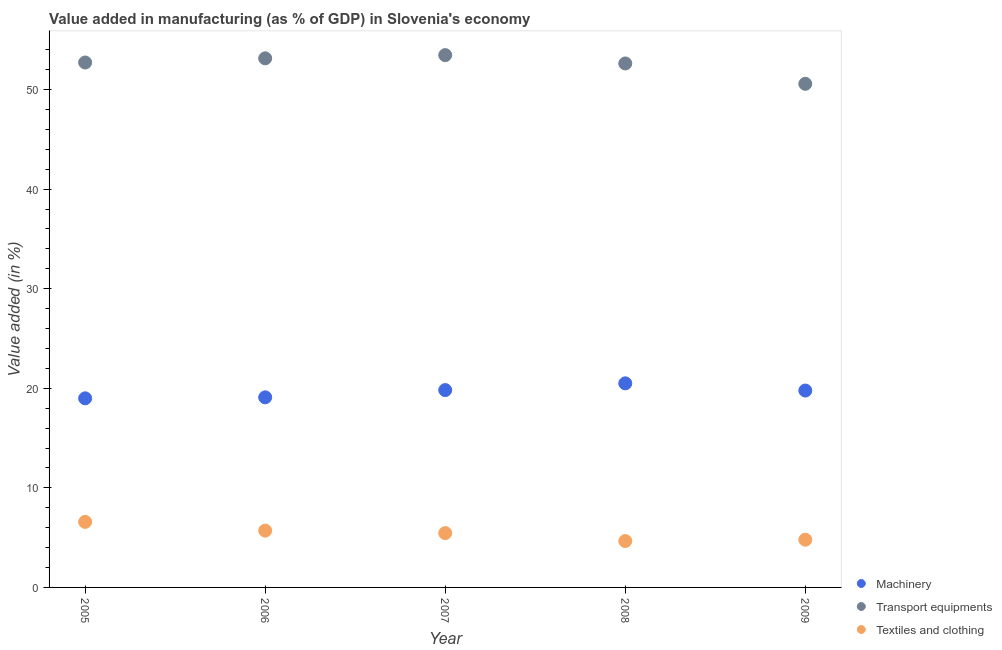Is the number of dotlines equal to the number of legend labels?
Your response must be concise. Yes. What is the value added in manufacturing textile and clothing in 2006?
Your answer should be very brief. 5.7. Across all years, what is the maximum value added in manufacturing textile and clothing?
Your answer should be very brief. 6.58. Across all years, what is the minimum value added in manufacturing machinery?
Give a very brief answer. 18.99. In which year was the value added in manufacturing transport equipments maximum?
Ensure brevity in your answer.  2007. What is the total value added in manufacturing machinery in the graph?
Make the answer very short. 98.16. What is the difference between the value added in manufacturing machinery in 2006 and that in 2008?
Ensure brevity in your answer.  -1.41. What is the difference between the value added in manufacturing machinery in 2007 and the value added in manufacturing transport equipments in 2005?
Your answer should be compact. -32.9. What is the average value added in manufacturing textile and clothing per year?
Your answer should be compact. 5.44. In the year 2008, what is the difference between the value added in manufacturing transport equipments and value added in manufacturing machinery?
Offer a very short reply. 32.12. In how many years, is the value added in manufacturing machinery greater than 10 %?
Ensure brevity in your answer.  5. What is the ratio of the value added in manufacturing transport equipments in 2006 to that in 2009?
Your answer should be compact. 1.05. Is the difference between the value added in manufacturing machinery in 2005 and 2007 greater than the difference between the value added in manufacturing transport equipments in 2005 and 2007?
Your response must be concise. No. What is the difference between the highest and the second highest value added in manufacturing textile and clothing?
Your response must be concise. 0.88. What is the difference between the highest and the lowest value added in manufacturing machinery?
Your answer should be compact. 1.51. In how many years, is the value added in manufacturing machinery greater than the average value added in manufacturing machinery taken over all years?
Offer a very short reply. 3. Is the sum of the value added in manufacturing transport equipments in 2007 and 2008 greater than the maximum value added in manufacturing machinery across all years?
Provide a succinct answer. Yes. Is it the case that in every year, the sum of the value added in manufacturing machinery and value added in manufacturing transport equipments is greater than the value added in manufacturing textile and clothing?
Your answer should be compact. Yes. Does the value added in manufacturing textile and clothing monotonically increase over the years?
Keep it short and to the point. No. Is the value added in manufacturing textile and clothing strictly greater than the value added in manufacturing machinery over the years?
Provide a succinct answer. No. How many dotlines are there?
Your answer should be compact. 3. How many years are there in the graph?
Ensure brevity in your answer.  5. What is the difference between two consecutive major ticks on the Y-axis?
Offer a terse response. 10. Are the values on the major ticks of Y-axis written in scientific E-notation?
Offer a terse response. No. Does the graph contain any zero values?
Give a very brief answer. No. Does the graph contain grids?
Your response must be concise. No. Where does the legend appear in the graph?
Your response must be concise. Bottom right. What is the title of the graph?
Your answer should be very brief. Value added in manufacturing (as % of GDP) in Slovenia's economy. What is the label or title of the X-axis?
Your answer should be very brief. Year. What is the label or title of the Y-axis?
Keep it short and to the point. Value added (in %). What is the Value added (in %) of Machinery in 2005?
Your response must be concise. 18.99. What is the Value added (in %) of Transport equipments in 2005?
Offer a very short reply. 52.71. What is the Value added (in %) in Textiles and clothing in 2005?
Keep it short and to the point. 6.58. What is the Value added (in %) in Machinery in 2006?
Your response must be concise. 19.09. What is the Value added (in %) of Transport equipments in 2006?
Ensure brevity in your answer.  53.13. What is the Value added (in %) of Textiles and clothing in 2006?
Provide a short and direct response. 5.7. What is the Value added (in %) in Machinery in 2007?
Offer a terse response. 19.82. What is the Value added (in %) in Transport equipments in 2007?
Offer a very short reply. 53.46. What is the Value added (in %) in Textiles and clothing in 2007?
Offer a very short reply. 5.45. What is the Value added (in %) in Machinery in 2008?
Provide a succinct answer. 20.5. What is the Value added (in %) in Transport equipments in 2008?
Give a very brief answer. 52.62. What is the Value added (in %) of Textiles and clothing in 2008?
Make the answer very short. 4.66. What is the Value added (in %) in Machinery in 2009?
Your response must be concise. 19.77. What is the Value added (in %) of Transport equipments in 2009?
Make the answer very short. 50.57. What is the Value added (in %) in Textiles and clothing in 2009?
Provide a short and direct response. 4.79. Across all years, what is the maximum Value added (in %) in Machinery?
Your answer should be compact. 20.5. Across all years, what is the maximum Value added (in %) of Transport equipments?
Offer a very short reply. 53.46. Across all years, what is the maximum Value added (in %) in Textiles and clothing?
Offer a very short reply. 6.58. Across all years, what is the minimum Value added (in %) of Machinery?
Offer a terse response. 18.99. Across all years, what is the minimum Value added (in %) of Transport equipments?
Ensure brevity in your answer.  50.57. Across all years, what is the minimum Value added (in %) in Textiles and clothing?
Your answer should be very brief. 4.66. What is the total Value added (in %) in Machinery in the graph?
Your response must be concise. 98.16. What is the total Value added (in %) of Transport equipments in the graph?
Keep it short and to the point. 262.49. What is the total Value added (in %) of Textiles and clothing in the graph?
Your answer should be very brief. 27.19. What is the difference between the Value added (in %) in Machinery in 2005 and that in 2006?
Keep it short and to the point. -0.1. What is the difference between the Value added (in %) in Transport equipments in 2005 and that in 2006?
Provide a succinct answer. -0.42. What is the difference between the Value added (in %) of Textiles and clothing in 2005 and that in 2006?
Provide a short and direct response. 0.88. What is the difference between the Value added (in %) of Machinery in 2005 and that in 2007?
Give a very brief answer. -0.83. What is the difference between the Value added (in %) in Transport equipments in 2005 and that in 2007?
Keep it short and to the point. -0.74. What is the difference between the Value added (in %) of Textiles and clothing in 2005 and that in 2007?
Your response must be concise. 1.13. What is the difference between the Value added (in %) in Machinery in 2005 and that in 2008?
Provide a succinct answer. -1.51. What is the difference between the Value added (in %) of Transport equipments in 2005 and that in 2008?
Your answer should be compact. 0.1. What is the difference between the Value added (in %) of Textiles and clothing in 2005 and that in 2008?
Make the answer very short. 1.93. What is the difference between the Value added (in %) in Machinery in 2005 and that in 2009?
Your answer should be very brief. -0.78. What is the difference between the Value added (in %) in Transport equipments in 2005 and that in 2009?
Offer a terse response. 2.14. What is the difference between the Value added (in %) in Textiles and clothing in 2005 and that in 2009?
Provide a short and direct response. 1.79. What is the difference between the Value added (in %) in Machinery in 2006 and that in 2007?
Your answer should be very brief. -0.73. What is the difference between the Value added (in %) of Transport equipments in 2006 and that in 2007?
Ensure brevity in your answer.  -0.32. What is the difference between the Value added (in %) in Textiles and clothing in 2006 and that in 2007?
Give a very brief answer. 0.25. What is the difference between the Value added (in %) of Machinery in 2006 and that in 2008?
Provide a succinct answer. -1.41. What is the difference between the Value added (in %) of Transport equipments in 2006 and that in 2008?
Make the answer very short. 0.51. What is the difference between the Value added (in %) of Textiles and clothing in 2006 and that in 2008?
Your answer should be compact. 1.05. What is the difference between the Value added (in %) in Machinery in 2006 and that in 2009?
Provide a succinct answer. -0.68. What is the difference between the Value added (in %) in Transport equipments in 2006 and that in 2009?
Provide a succinct answer. 2.56. What is the difference between the Value added (in %) of Textiles and clothing in 2006 and that in 2009?
Your response must be concise. 0.91. What is the difference between the Value added (in %) of Machinery in 2007 and that in 2008?
Ensure brevity in your answer.  -0.68. What is the difference between the Value added (in %) in Transport equipments in 2007 and that in 2008?
Ensure brevity in your answer.  0.84. What is the difference between the Value added (in %) of Textiles and clothing in 2007 and that in 2008?
Your response must be concise. 0.8. What is the difference between the Value added (in %) in Machinery in 2007 and that in 2009?
Make the answer very short. 0.05. What is the difference between the Value added (in %) in Transport equipments in 2007 and that in 2009?
Give a very brief answer. 2.88. What is the difference between the Value added (in %) in Textiles and clothing in 2007 and that in 2009?
Offer a terse response. 0.66. What is the difference between the Value added (in %) in Machinery in 2008 and that in 2009?
Provide a short and direct response. 0.72. What is the difference between the Value added (in %) in Transport equipments in 2008 and that in 2009?
Provide a succinct answer. 2.04. What is the difference between the Value added (in %) of Textiles and clothing in 2008 and that in 2009?
Ensure brevity in your answer.  -0.14. What is the difference between the Value added (in %) in Machinery in 2005 and the Value added (in %) in Transport equipments in 2006?
Give a very brief answer. -34.14. What is the difference between the Value added (in %) of Machinery in 2005 and the Value added (in %) of Textiles and clothing in 2006?
Offer a very short reply. 13.29. What is the difference between the Value added (in %) of Transport equipments in 2005 and the Value added (in %) of Textiles and clothing in 2006?
Your answer should be compact. 47.01. What is the difference between the Value added (in %) of Machinery in 2005 and the Value added (in %) of Transport equipments in 2007?
Offer a terse response. -34.47. What is the difference between the Value added (in %) of Machinery in 2005 and the Value added (in %) of Textiles and clothing in 2007?
Give a very brief answer. 13.54. What is the difference between the Value added (in %) in Transport equipments in 2005 and the Value added (in %) in Textiles and clothing in 2007?
Give a very brief answer. 47.26. What is the difference between the Value added (in %) of Machinery in 2005 and the Value added (in %) of Transport equipments in 2008?
Keep it short and to the point. -33.63. What is the difference between the Value added (in %) in Machinery in 2005 and the Value added (in %) in Textiles and clothing in 2008?
Ensure brevity in your answer.  14.33. What is the difference between the Value added (in %) in Transport equipments in 2005 and the Value added (in %) in Textiles and clothing in 2008?
Your answer should be very brief. 48.06. What is the difference between the Value added (in %) in Machinery in 2005 and the Value added (in %) in Transport equipments in 2009?
Your response must be concise. -31.58. What is the difference between the Value added (in %) in Machinery in 2005 and the Value added (in %) in Textiles and clothing in 2009?
Keep it short and to the point. 14.2. What is the difference between the Value added (in %) in Transport equipments in 2005 and the Value added (in %) in Textiles and clothing in 2009?
Provide a succinct answer. 47.92. What is the difference between the Value added (in %) in Machinery in 2006 and the Value added (in %) in Transport equipments in 2007?
Your response must be concise. -34.37. What is the difference between the Value added (in %) of Machinery in 2006 and the Value added (in %) of Textiles and clothing in 2007?
Keep it short and to the point. 13.63. What is the difference between the Value added (in %) in Transport equipments in 2006 and the Value added (in %) in Textiles and clothing in 2007?
Offer a terse response. 47.68. What is the difference between the Value added (in %) of Machinery in 2006 and the Value added (in %) of Transport equipments in 2008?
Your answer should be very brief. -33.53. What is the difference between the Value added (in %) of Machinery in 2006 and the Value added (in %) of Textiles and clothing in 2008?
Offer a very short reply. 14.43. What is the difference between the Value added (in %) of Transport equipments in 2006 and the Value added (in %) of Textiles and clothing in 2008?
Ensure brevity in your answer.  48.48. What is the difference between the Value added (in %) in Machinery in 2006 and the Value added (in %) in Transport equipments in 2009?
Keep it short and to the point. -31.48. What is the difference between the Value added (in %) in Machinery in 2006 and the Value added (in %) in Textiles and clothing in 2009?
Your response must be concise. 14.3. What is the difference between the Value added (in %) in Transport equipments in 2006 and the Value added (in %) in Textiles and clothing in 2009?
Offer a terse response. 48.34. What is the difference between the Value added (in %) in Machinery in 2007 and the Value added (in %) in Transport equipments in 2008?
Your response must be concise. -32.8. What is the difference between the Value added (in %) of Machinery in 2007 and the Value added (in %) of Textiles and clothing in 2008?
Give a very brief answer. 15.16. What is the difference between the Value added (in %) of Transport equipments in 2007 and the Value added (in %) of Textiles and clothing in 2008?
Keep it short and to the point. 48.8. What is the difference between the Value added (in %) in Machinery in 2007 and the Value added (in %) in Transport equipments in 2009?
Keep it short and to the point. -30.76. What is the difference between the Value added (in %) in Machinery in 2007 and the Value added (in %) in Textiles and clothing in 2009?
Keep it short and to the point. 15.02. What is the difference between the Value added (in %) in Transport equipments in 2007 and the Value added (in %) in Textiles and clothing in 2009?
Keep it short and to the point. 48.66. What is the difference between the Value added (in %) in Machinery in 2008 and the Value added (in %) in Transport equipments in 2009?
Ensure brevity in your answer.  -30.08. What is the difference between the Value added (in %) of Machinery in 2008 and the Value added (in %) of Textiles and clothing in 2009?
Offer a very short reply. 15.7. What is the difference between the Value added (in %) in Transport equipments in 2008 and the Value added (in %) in Textiles and clothing in 2009?
Offer a terse response. 47.83. What is the average Value added (in %) of Machinery per year?
Provide a short and direct response. 19.63. What is the average Value added (in %) of Transport equipments per year?
Your answer should be compact. 52.5. What is the average Value added (in %) in Textiles and clothing per year?
Provide a short and direct response. 5.44. In the year 2005, what is the difference between the Value added (in %) of Machinery and Value added (in %) of Transport equipments?
Give a very brief answer. -33.72. In the year 2005, what is the difference between the Value added (in %) of Machinery and Value added (in %) of Textiles and clothing?
Your answer should be very brief. 12.41. In the year 2005, what is the difference between the Value added (in %) of Transport equipments and Value added (in %) of Textiles and clothing?
Offer a terse response. 46.13. In the year 2006, what is the difference between the Value added (in %) of Machinery and Value added (in %) of Transport equipments?
Ensure brevity in your answer.  -34.04. In the year 2006, what is the difference between the Value added (in %) in Machinery and Value added (in %) in Textiles and clothing?
Your response must be concise. 13.38. In the year 2006, what is the difference between the Value added (in %) of Transport equipments and Value added (in %) of Textiles and clothing?
Your response must be concise. 47.43. In the year 2007, what is the difference between the Value added (in %) in Machinery and Value added (in %) in Transport equipments?
Your answer should be compact. -33.64. In the year 2007, what is the difference between the Value added (in %) of Machinery and Value added (in %) of Textiles and clothing?
Give a very brief answer. 14.36. In the year 2007, what is the difference between the Value added (in %) in Transport equipments and Value added (in %) in Textiles and clothing?
Give a very brief answer. 48. In the year 2008, what is the difference between the Value added (in %) of Machinery and Value added (in %) of Transport equipments?
Provide a short and direct response. -32.12. In the year 2008, what is the difference between the Value added (in %) of Machinery and Value added (in %) of Textiles and clothing?
Make the answer very short. 15.84. In the year 2008, what is the difference between the Value added (in %) of Transport equipments and Value added (in %) of Textiles and clothing?
Your answer should be very brief. 47.96. In the year 2009, what is the difference between the Value added (in %) of Machinery and Value added (in %) of Transport equipments?
Your answer should be compact. -30.8. In the year 2009, what is the difference between the Value added (in %) of Machinery and Value added (in %) of Textiles and clothing?
Ensure brevity in your answer.  14.98. In the year 2009, what is the difference between the Value added (in %) of Transport equipments and Value added (in %) of Textiles and clothing?
Your response must be concise. 45.78. What is the ratio of the Value added (in %) of Textiles and clothing in 2005 to that in 2006?
Offer a very short reply. 1.15. What is the ratio of the Value added (in %) in Transport equipments in 2005 to that in 2007?
Offer a very short reply. 0.99. What is the ratio of the Value added (in %) of Textiles and clothing in 2005 to that in 2007?
Keep it short and to the point. 1.21. What is the ratio of the Value added (in %) in Machinery in 2005 to that in 2008?
Provide a succinct answer. 0.93. What is the ratio of the Value added (in %) of Textiles and clothing in 2005 to that in 2008?
Your answer should be compact. 1.41. What is the ratio of the Value added (in %) in Machinery in 2005 to that in 2009?
Offer a very short reply. 0.96. What is the ratio of the Value added (in %) in Transport equipments in 2005 to that in 2009?
Provide a succinct answer. 1.04. What is the ratio of the Value added (in %) in Textiles and clothing in 2005 to that in 2009?
Your response must be concise. 1.37. What is the ratio of the Value added (in %) in Machinery in 2006 to that in 2007?
Keep it short and to the point. 0.96. What is the ratio of the Value added (in %) of Textiles and clothing in 2006 to that in 2007?
Offer a terse response. 1.05. What is the ratio of the Value added (in %) of Machinery in 2006 to that in 2008?
Make the answer very short. 0.93. What is the ratio of the Value added (in %) in Transport equipments in 2006 to that in 2008?
Provide a short and direct response. 1.01. What is the ratio of the Value added (in %) of Textiles and clothing in 2006 to that in 2008?
Ensure brevity in your answer.  1.23. What is the ratio of the Value added (in %) of Machinery in 2006 to that in 2009?
Offer a terse response. 0.97. What is the ratio of the Value added (in %) of Transport equipments in 2006 to that in 2009?
Make the answer very short. 1.05. What is the ratio of the Value added (in %) in Textiles and clothing in 2006 to that in 2009?
Provide a short and direct response. 1.19. What is the ratio of the Value added (in %) of Machinery in 2007 to that in 2008?
Give a very brief answer. 0.97. What is the ratio of the Value added (in %) of Transport equipments in 2007 to that in 2008?
Your response must be concise. 1.02. What is the ratio of the Value added (in %) of Textiles and clothing in 2007 to that in 2008?
Keep it short and to the point. 1.17. What is the ratio of the Value added (in %) of Transport equipments in 2007 to that in 2009?
Ensure brevity in your answer.  1.06. What is the ratio of the Value added (in %) in Textiles and clothing in 2007 to that in 2009?
Provide a succinct answer. 1.14. What is the ratio of the Value added (in %) of Machinery in 2008 to that in 2009?
Keep it short and to the point. 1.04. What is the ratio of the Value added (in %) of Transport equipments in 2008 to that in 2009?
Your answer should be very brief. 1.04. What is the ratio of the Value added (in %) in Textiles and clothing in 2008 to that in 2009?
Provide a short and direct response. 0.97. What is the difference between the highest and the second highest Value added (in %) of Machinery?
Provide a short and direct response. 0.68. What is the difference between the highest and the second highest Value added (in %) in Transport equipments?
Your response must be concise. 0.32. What is the difference between the highest and the second highest Value added (in %) of Textiles and clothing?
Ensure brevity in your answer.  0.88. What is the difference between the highest and the lowest Value added (in %) in Machinery?
Offer a terse response. 1.51. What is the difference between the highest and the lowest Value added (in %) in Transport equipments?
Your answer should be compact. 2.88. What is the difference between the highest and the lowest Value added (in %) in Textiles and clothing?
Keep it short and to the point. 1.93. 